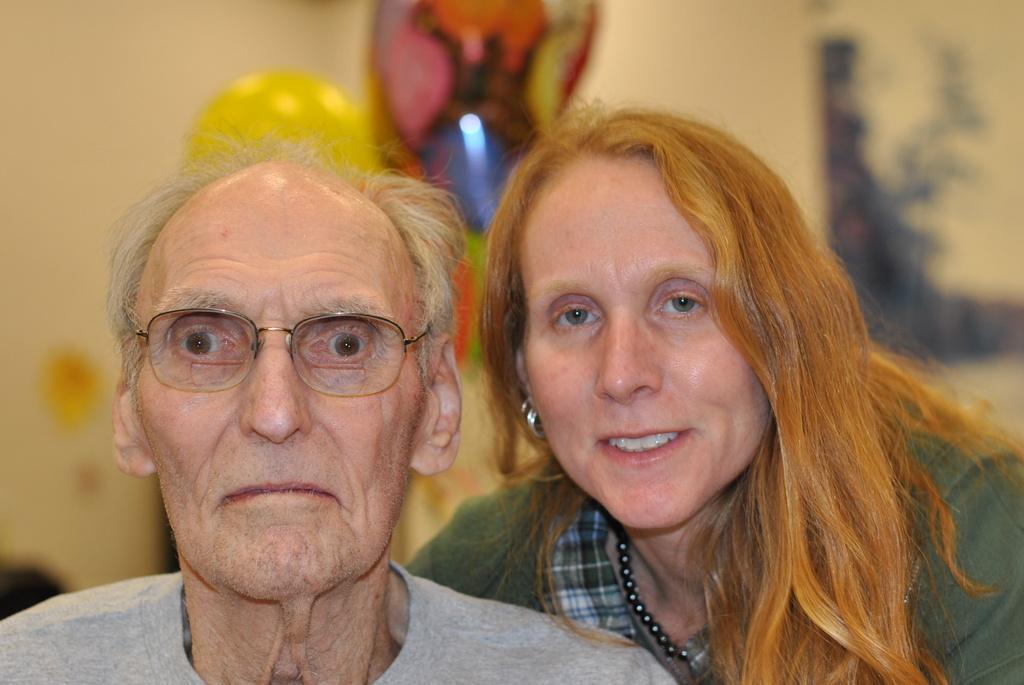How would you summarize this image in a sentence or two? In this image I can see a two people wearing ash and green color dress. Background is in cream wall and blurred. 